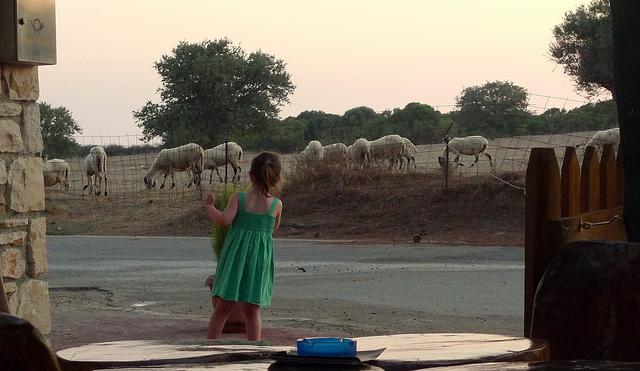What is the sex of the baby?
Answer briefly. Female. Is that a mother pointing?
Keep it brief. No. What animal is there?
Keep it brief. Goat. What is this object?
Give a very brief answer. Girl. What color is the girls dress?
Be succinct. Green. Where is an ashtray?
Be succinct. Table. 